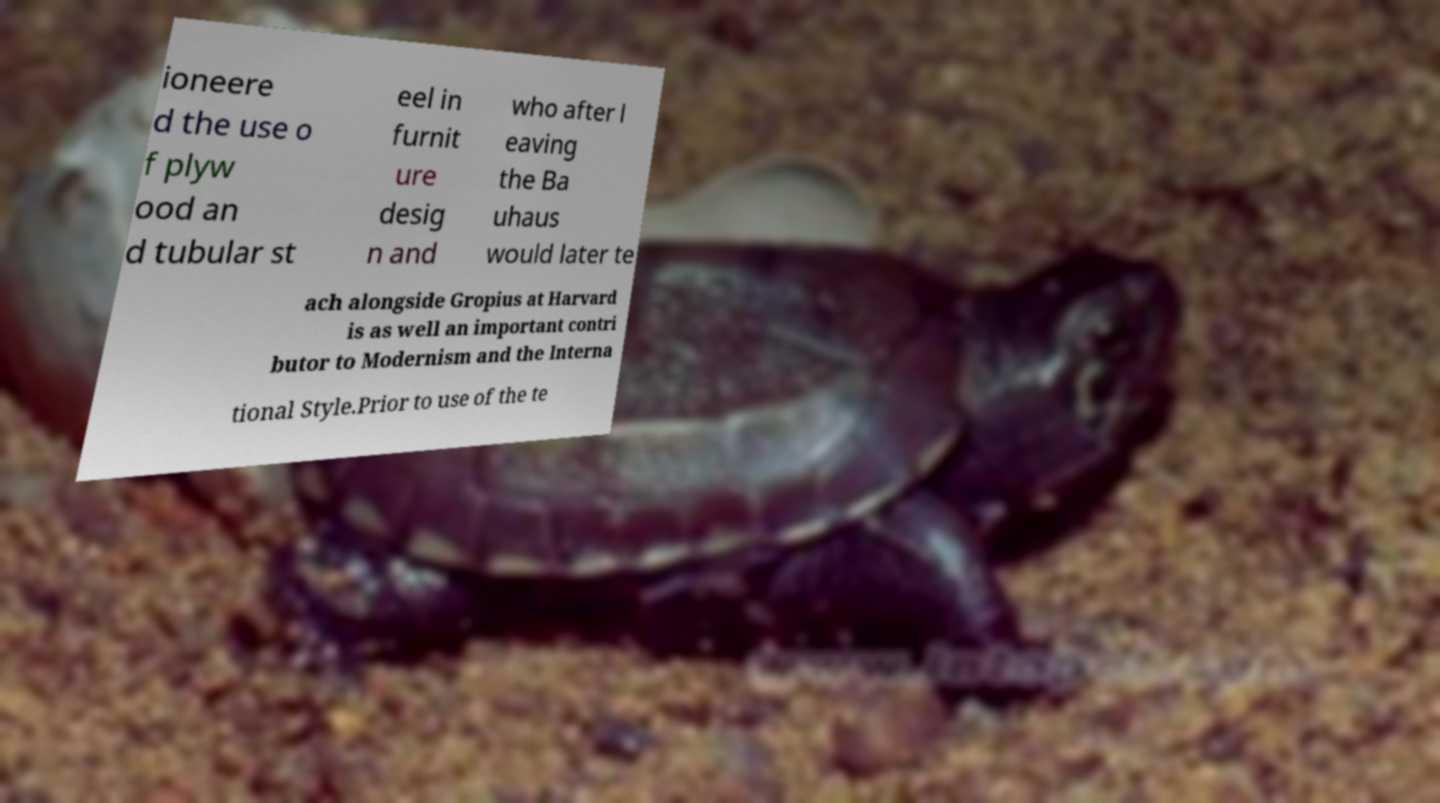Can you read and provide the text displayed in the image?This photo seems to have some interesting text. Can you extract and type it out for me? ioneere d the use o f plyw ood an d tubular st eel in furnit ure desig n and who after l eaving the Ba uhaus would later te ach alongside Gropius at Harvard is as well an important contri butor to Modernism and the Interna tional Style.Prior to use of the te 